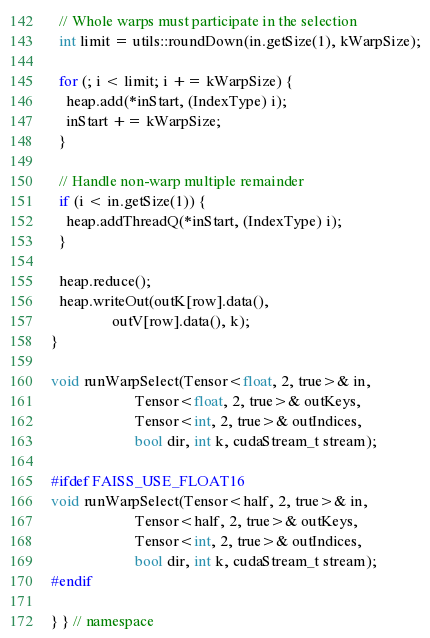Convert code to text. <code><loc_0><loc_0><loc_500><loc_500><_Cuda_>  // Whole warps must participate in the selection
  int limit = utils::roundDown(in.getSize(1), kWarpSize);

  for (; i < limit; i += kWarpSize) {
    heap.add(*inStart, (IndexType) i);
    inStart += kWarpSize;
  }

  // Handle non-warp multiple remainder
  if (i < in.getSize(1)) {
    heap.addThreadQ(*inStart, (IndexType) i);
  }

  heap.reduce();
  heap.writeOut(outK[row].data(),
                outV[row].data(), k);
}

void runWarpSelect(Tensor<float, 2, true>& in,
                      Tensor<float, 2, true>& outKeys,
                      Tensor<int, 2, true>& outIndices,
                      bool dir, int k, cudaStream_t stream);

#ifdef FAISS_USE_FLOAT16
void runWarpSelect(Tensor<half, 2, true>& in,
                      Tensor<half, 2, true>& outKeys,
                      Tensor<int, 2, true>& outIndices,
                      bool dir, int k, cudaStream_t stream);
#endif

} } // namespace
</code> 